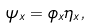<formula> <loc_0><loc_0><loc_500><loc_500>\psi _ { x } = \phi _ { x } \eta _ { x } ,</formula> 